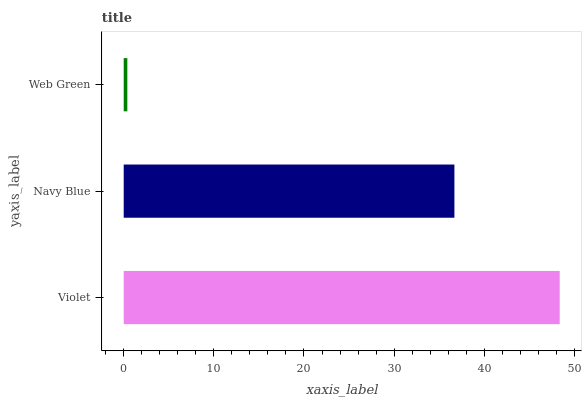Is Web Green the minimum?
Answer yes or no. Yes. Is Violet the maximum?
Answer yes or no. Yes. Is Navy Blue the minimum?
Answer yes or no. No. Is Navy Blue the maximum?
Answer yes or no. No. Is Violet greater than Navy Blue?
Answer yes or no. Yes. Is Navy Blue less than Violet?
Answer yes or no. Yes. Is Navy Blue greater than Violet?
Answer yes or no. No. Is Violet less than Navy Blue?
Answer yes or no. No. Is Navy Blue the high median?
Answer yes or no. Yes. Is Navy Blue the low median?
Answer yes or no. Yes. Is Web Green the high median?
Answer yes or no. No. Is Web Green the low median?
Answer yes or no. No. 